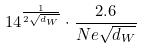<formula> <loc_0><loc_0><loc_500><loc_500>1 4 ^ { \frac { 1 } { 2 \sqrt { d _ { W } } } } \cdot \frac { 2 . 6 } { N e \sqrt { d _ { W } } }</formula> 